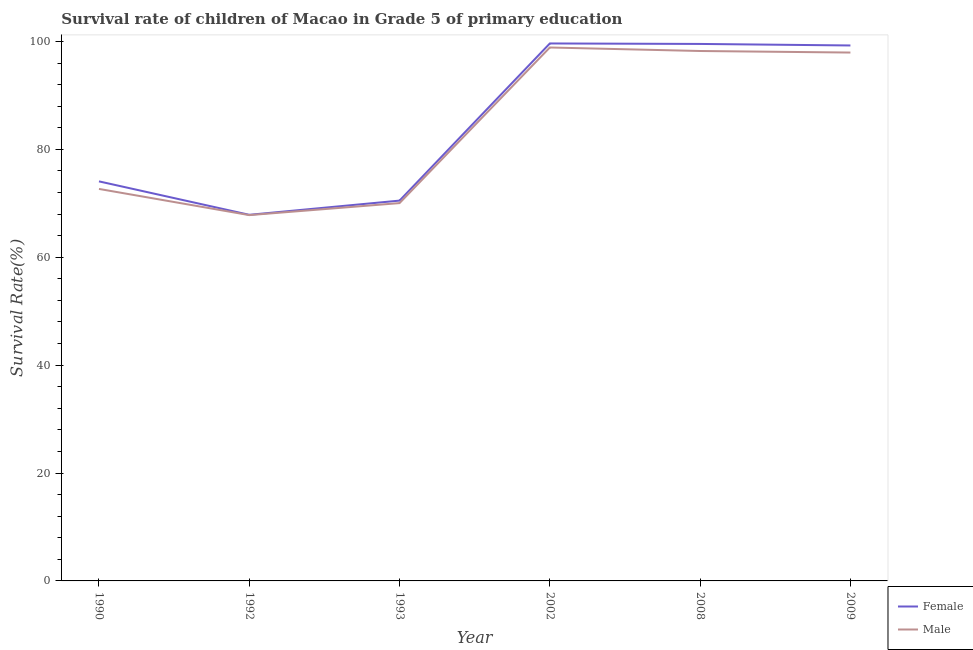How many different coloured lines are there?
Keep it short and to the point. 2. What is the survival rate of male students in primary education in 1992?
Offer a terse response. 67.81. Across all years, what is the maximum survival rate of male students in primary education?
Offer a very short reply. 98.87. Across all years, what is the minimum survival rate of female students in primary education?
Give a very brief answer. 67.86. In which year was the survival rate of male students in primary education minimum?
Offer a very short reply. 1992. What is the total survival rate of male students in primary education in the graph?
Your answer should be very brief. 505.54. What is the difference between the survival rate of female students in primary education in 1993 and that in 2008?
Your answer should be compact. -29.04. What is the difference between the survival rate of male students in primary education in 1993 and the survival rate of female students in primary education in 2008?
Offer a very short reply. -29.5. What is the average survival rate of female students in primary education per year?
Ensure brevity in your answer.  85.14. In the year 1990, what is the difference between the survival rate of male students in primary education and survival rate of female students in primary education?
Your answer should be very brief. -1.4. What is the ratio of the survival rate of female students in primary education in 1992 to that in 2002?
Give a very brief answer. 0.68. Is the survival rate of male students in primary education in 1990 less than that in 2002?
Give a very brief answer. Yes. What is the difference between the highest and the second highest survival rate of female students in primary education?
Keep it short and to the point. 0.09. What is the difference between the highest and the lowest survival rate of male students in primary education?
Make the answer very short. 31.07. In how many years, is the survival rate of male students in primary education greater than the average survival rate of male students in primary education taken over all years?
Keep it short and to the point. 3. Is the survival rate of male students in primary education strictly less than the survival rate of female students in primary education over the years?
Your response must be concise. Yes. What is the difference between two consecutive major ticks on the Y-axis?
Offer a terse response. 20. Are the values on the major ticks of Y-axis written in scientific E-notation?
Offer a very short reply. No. Does the graph contain grids?
Your answer should be compact. No. How are the legend labels stacked?
Your response must be concise. Vertical. What is the title of the graph?
Your response must be concise. Survival rate of children of Macao in Grade 5 of primary education. Does "Merchandise exports" appear as one of the legend labels in the graph?
Ensure brevity in your answer.  No. What is the label or title of the X-axis?
Keep it short and to the point. Year. What is the label or title of the Y-axis?
Give a very brief answer. Survival Rate(%). What is the Survival Rate(%) of Female in 1990?
Keep it short and to the point. 74.06. What is the Survival Rate(%) of Male in 1990?
Offer a terse response. 72.66. What is the Survival Rate(%) of Female in 1992?
Make the answer very short. 67.86. What is the Survival Rate(%) of Male in 1992?
Provide a short and direct response. 67.81. What is the Survival Rate(%) of Female in 1993?
Your answer should be very brief. 70.49. What is the Survival Rate(%) of Male in 1993?
Your response must be concise. 70.03. What is the Survival Rate(%) in Female in 2002?
Keep it short and to the point. 99.62. What is the Survival Rate(%) in Male in 2002?
Provide a short and direct response. 98.87. What is the Survival Rate(%) of Female in 2008?
Ensure brevity in your answer.  99.53. What is the Survival Rate(%) of Male in 2008?
Make the answer very short. 98.22. What is the Survival Rate(%) in Female in 2009?
Make the answer very short. 99.25. What is the Survival Rate(%) of Male in 2009?
Your response must be concise. 97.94. Across all years, what is the maximum Survival Rate(%) in Female?
Your answer should be very brief. 99.62. Across all years, what is the maximum Survival Rate(%) of Male?
Give a very brief answer. 98.87. Across all years, what is the minimum Survival Rate(%) of Female?
Your answer should be compact. 67.86. Across all years, what is the minimum Survival Rate(%) of Male?
Offer a very short reply. 67.81. What is the total Survival Rate(%) of Female in the graph?
Keep it short and to the point. 510.82. What is the total Survival Rate(%) in Male in the graph?
Give a very brief answer. 505.54. What is the difference between the Survival Rate(%) in Female in 1990 and that in 1992?
Make the answer very short. 6.2. What is the difference between the Survival Rate(%) of Male in 1990 and that in 1992?
Your answer should be compact. 4.85. What is the difference between the Survival Rate(%) of Female in 1990 and that in 1993?
Keep it short and to the point. 3.57. What is the difference between the Survival Rate(%) of Male in 1990 and that in 1993?
Your response must be concise. 2.63. What is the difference between the Survival Rate(%) in Female in 1990 and that in 2002?
Provide a short and direct response. -25.56. What is the difference between the Survival Rate(%) in Male in 1990 and that in 2002?
Your response must be concise. -26.21. What is the difference between the Survival Rate(%) of Female in 1990 and that in 2008?
Give a very brief answer. -25.47. What is the difference between the Survival Rate(%) of Male in 1990 and that in 2008?
Provide a short and direct response. -25.56. What is the difference between the Survival Rate(%) of Female in 1990 and that in 2009?
Offer a very short reply. -25.19. What is the difference between the Survival Rate(%) of Male in 1990 and that in 2009?
Make the answer very short. -25.28. What is the difference between the Survival Rate(%) in Female in 1992 and that in 1993?
Offer a terse response. -2.63. What is the difference between the Survival Rate(%) in Male in 1992 and that in 1993?
Provide a short and direct response. -2.23. What is the difference between the Survival Rate(%) in Female in 1992 and that in 2002?
Your answer should be compact. -31.76. What is the difference between the Survival Rate(%) in Male in 1992 and that in 2002?
Provide a succinct answer. -31.07. What is the difference between the Survival Rate(%) of Female in 1992 and that in 2008?
Provide a succinct answer. -31.67. What is the difference between the Survival Rate(%) in Male in 1992 and that in 2008?
Provide a succinct answer. -30.42. What is the difference between the Survival Rate(%) of Female in 1992 and that in 2009?
Give a very brief answer. -31.39. What is the difference between the Survival Rate(%) of Male in 1992 and that in 2009?
Make the answer very short. -30.13. What is the difference between the Survival Rate(%) of Female in 1993 and that in 2002?
Keep it short and to the point. -29.13. What is the difference between the Survival Rate(%) in Male in 1993 and that in 2002?
Your response must be concise. -28.84. What is the difference between the Survival Rate(%) of Female in 1993 and that in 2008?
Keep it short and to the point. -29.04. What is the difference between the Survival Rate(%) in Male in 1993 and that in 2008?
Give a very brief answer. -28.19. What is the difference between the Survival Rate(%) in Female in 1993 and that in 2009?
Keep it short and to the point. -28.76. What is the difference between the Survival Rate(%) of Male in 1993 and that in 2009?
Offer a terse response. -27.91. What is the difference between the Survival Rate(%) of Female in 2002 and that in 2008?
Offer a terse response. 0.09. What is the difference between the Survival Rate(%) in Male in 2002 and that in 2008?
Your response must be concise. 0.65. What is the difference between the Survival Rate(%) of Female in 2002 and that in 2009?
Provide a succinct answer. 0.37. What is the difference between the Survival Rate(%) of Male in 2002 and that in 2009?
Offer a terse response. 0.94. What is the difference between the Survival Rate(%) in Female in 2008 and that in 2009?
Make the answer very short. 0.28. What is the difference between the Survival Rate(%) of Male in 2008 and that in 2009?
Give a very brief answer. 0.29. What is the difference between the Survival Rate(%) of Female in 1990 and the Survival Rate(%) of Male in 1992?
Offer a very short reply. 6.25. What is the difference between the Survival Rate(%) in Female in 1990 and the Survival Rate(%) in Male in 1993?
Your response must be concise. 4.03. What is the difference between the Survival Rate(%) in Female in 1990 and the Survival Rate(%) in Male in 2002?
Provide a short and direct response. -24.82. What is the difference between the Survival Rate(%) in Female in 1990 and the Survival Rate(%) in Male in 2008?
Keep it short and to the point. -24.16. What is the difference between the Survival Rate(%) of Female in 1990 and the Survival Rate(%) of Male in 2009?
Your answer should be compact. -23.88. What is the difference between the Survival Rate(%) in Female in 1992 and the Survival Rate(%) in Male in 1993?
Provide a succinct answer. -2.17. What is the difference between the Survival Rate(%) of Female in 1992 and the Survival Rate(%) of Male in 2002?
Offer a very short reply. -31.01. What is the difference between the Survival Rate(%) in Female in 1992 and the Survival Rate(%) in Male in 2008?
Provide a succinct answer. -30.36. What is the difference between the Survival Rate(%) of Female in 1992 and the Survival Rate(%) of Male in 2009?
Keep it short and to the point. -30.08. What is the difference between the Survival Rate(%) in Female in 1993 and the Survival Rate(%) in Male in 2002?
Provide a succinct answer. -28.38. What is the difference between the Survival Rate(%) of Female in 1993 and the Survival Rate(%) of Male in 2008?
Offer a very short reply. -27.73. What is the difference between the Survival Rate(%) of Female in 1993 and the Survival Rate(%) of Male in 2009?
Your response must be concise. -27.44. What is the difference between the Survival Rate(%) of Female in 2002 and the Survival Rate(%) of Male in 2008?
Provide a succinct answer. 1.4. What is the difference between the Survival Rate(%) of Female in 2002 and the Survival Rate(%) of Male in 2009?
Your answer should be very brief. 1.68. What is the difference between the Survival Rate(%) in Female in 2008 and the Survival Rate(%) in Male in 2009?
Give a very brief answer. 1.6. What is the average Survival Rate(%) in Female per year?
Provide a succinct answer. 85.14. What is the average Survival Rate(%) in Male per year?
Keep it short and to the point. 84.26. In the year 1990, what is the difference between the Survival Rate(%) in Female and Survival Rate(%) in Male?
Your response must be concise. 1.4. In the year 1992, what is the difference between the Survival Rate(%) of Female and Survival Rate(%) of Male?
Keep it short and to the point. 0.05. In the year 1993, what is the difference between the Survival Rate(%) of Female and Survival Rate(%) of Male?
Make the answer very short. 0.46. In the year 2002, what is the difference between the Survival Rate(%) of Female and Survival Rate(%) of Male?
Keep it short and to the point. 0.75. In the year 2008, what is the difference between the Survival Rate(%) in Female and Survival Rate(%) in Male?
Your response must be concise. 1.31. In the year 2009, what is the difference between the Survival Rate(%) of Female and Survival Rate(%) of Male?
Offer a terse response. 1.31. What is the ratio of the Survival Rate(%) in Female in 1990 to that in 1992?
Keep it short and to the point. 1.09. What is the ratio of the Survival Rate(%) of Male in 1990 to that in 1992?
Provide a succinct answer. 1.07. What is the ratio of the Survival Rate(%) in Female in 1990 to that in 1993?
Your answer should be compact. 1.05. What is the ratio of the Survival Rate(%) in Male in 1990 to that in 1993?
Give a very brief answer. 1.04. What is the ratio of the Survival Rate(%) in Female in 1990 to that in 2002?
Give a very brief answer. 0.74. What is the ratio of the Survival Rate(%) in Male in 1990 to that in 2002?
Your answer should be compact. 0.73. What is the ratio of the Survival Rate(%) of Female in 1990 to that in 2008?
Your response must be concise. 0.74. What is the ratio of the Survival Rate(%) in Male in 1990 to that in 2008?
Your answer should be very brief. 0.74. What is the ratio of the Survival Rate(%) in Female in 1990 to that in 2009?
Your answer should be very brief. 0.75. What is the ratio of the Survival Rate(%) of Male in 1990 to that in 2009?
Ensure brevity in your answer.  0.74. What is the ratio of the Survival Rate(%) in Female in 1992 to that in 1993?
Offer a very short reply. 0.96. What is the ratio of the Survival Rate(%) of Male in 1992 to that in 1993?
Provide a succinct answer. 0.97. What is the ratio of the Survival Rate(%) in Female in 1992 to that in 2002?
Your response must be concise. 0.68. What is the ratio of the Survival Rate(%) in Male in 1992 to that in 2002?
Ensure brevity in your answer.  0.69. What is the ratio of the Survival Rate(%) of Female in 1992 to that in 2008?
Make the answer very short. 0.68. What is the ratio of the Survival Rate(%) in Male in 1992 to that in 2008?
Keep it short and to the point. 0.69. What is the ratio of the Survival Rate(%) in Female in 1992 to that in 2009?
Make the answer very short. 0.68. What is the ratio of the Survival Rate(%) in Male in 1992 to that in 2009?
Offer a terse response. 0.69. What is the ratio of the Survival Rate(%) of Female in 1993 to that in 2002?
Your answer should be very brief. 0.71. What is the ratio of the Survival Rate(%) in Male in 1993 to that in 2002?
Offer a terse response. 0.71. What is the ratio of the Survival Rate(%) of Female in 1993 to that in 2008?
Your response must be concise. 0.71. What is the ratio of the Survival Rate(%) in Male in 1993 to that in 2008?
Give a very brief answer. 0.71. What is the ratio of the Survival Rate(%) of Female in 1993 to that in 2009?
Keep it short and to the point. 0.71. What is the ratio of the Survival Rate(%) in Male in 1993 to that in 2009?
Provide a succinct answer. 0.72. What is the ratio of the Survival Rate(%) of Female in 2002 to that in 2008?
Your response must be concise. 1. What is the ratio of the Survival Rate(%) in Male in 2002 to that in 2008?
Provide a succinct answer. 1.01. What is the ratio of the Survival Rate(%) of Female in 2002 to that in 2009?
Offer a terse response. 1. What is the ratio of the Survival Rate(%) of Male in 2002 to that in 2009?
Your answer should be compact. 1.01. What is the difference between the highest and the second highest Survival Rate(%) in Female?
Make the answer very short. 0.09. What is the difference between the highest and the second highest Survival Rate(%) of Male?
Offer a very short reply. 0.65. What is the difference between the highest and the lowest Survival Rate(%) in Female?
Your answer should be compact. 31.76. What is the difference between the highest and the lowest Survival Rate(%) in Male?
Offer a terse response. 31.07. 